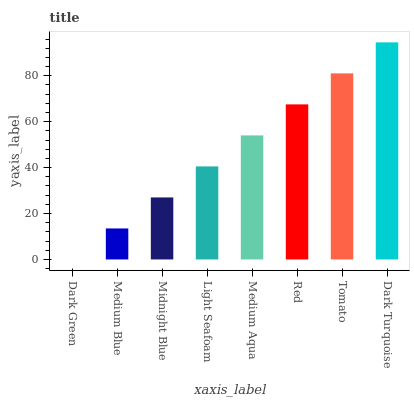Is Medium Blue the minimum?
Answer yes or no. No. Is Medium Blue the maximum?
Answer yes or no. No. Is Medium Blue greater than Dark Green?
Answer yes or no. Yes. Is Dark Green less than Medium Blue?
Answer yes or no. Yes. Is Dark Green greater than Medium Blue?
Answer yes or no. No. Is Medium Blue less than Dark Green?
Answer yes or no. No. Is Medium Aqua the high median?
Answer yes or no. Yes. Is Light Seafoam the low median?
Answer yes or no. Yes. Is Dark Green the high median?
Answer yes or no. No. Is Dark Green the low median?
Answer yes or no. No. 